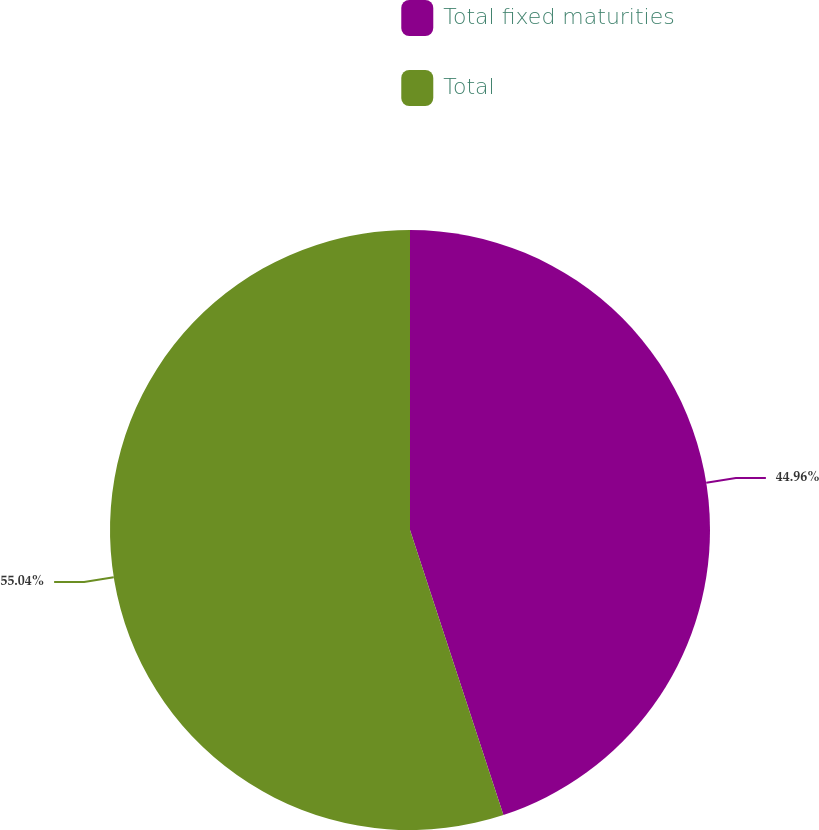Convert chart. <chart><loc_0><loc_0><loc_500><loc_500><pie_chart><fcel>Total fixed maturities<fcel>Total<nl><fcel>44.96%<fcel>55.04%<nl></chart> 